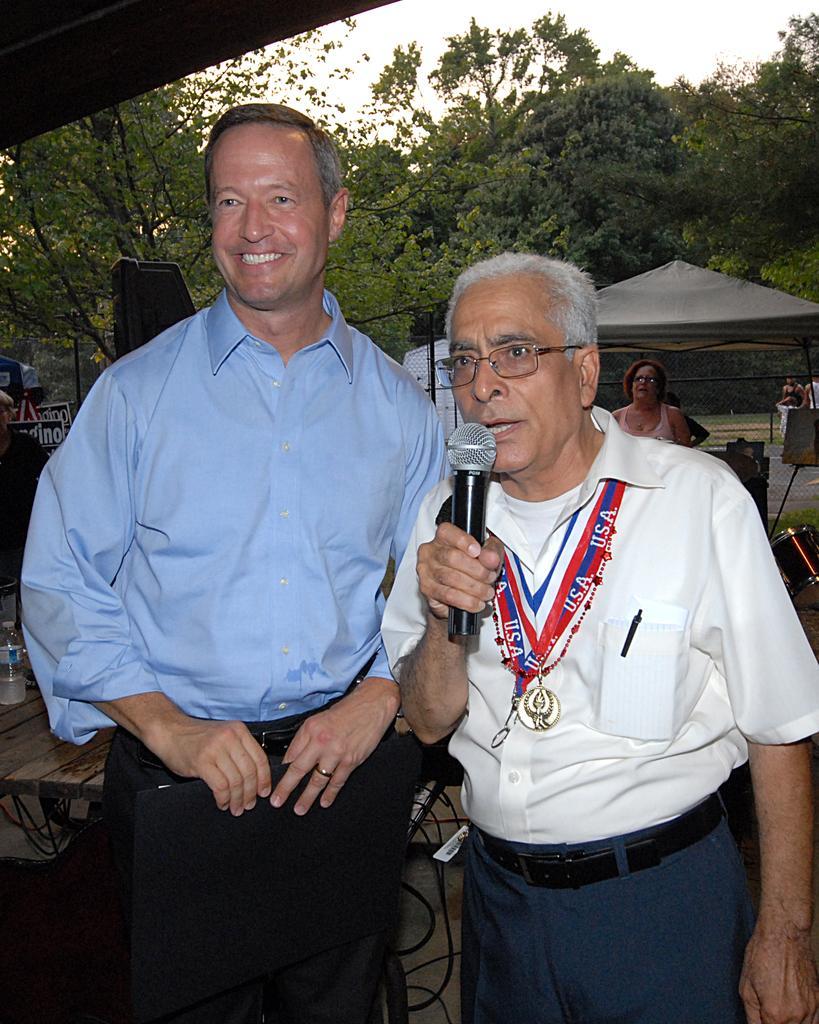Describe this image in one or two sentences. In this image there are two persons who are standing. On the left side there is one person who is standing is wearing a blue shirt and he is smiling. On the right side there is one person who is wearing white shirt and he is holding a mike and it seems that he is talking and he is wearing spectacles. On the top of the image there are some plants and sky and on the middle of the right side of the image there is one tent and beside that rent one woman is there and on the left side there are some trees. 